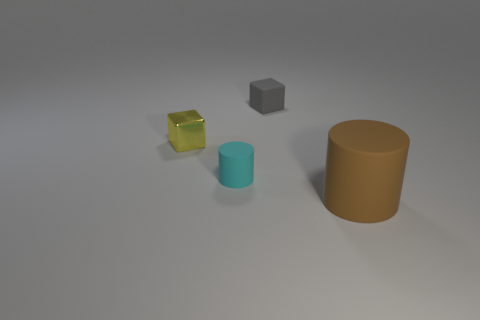Subtract all gray blocks. How many blocks are left? 1 Subtract 1 cylinders. How many cylinders are left? 1 Add 2 big red objects. How many objects exist? 6 Subtract all gray blocks. Subtract all gray cylinders. How many blocks are left? 1 Subtract all yellow cubes. Subtract all tiny things. How many objects are left? 0 Add 4 small cyan cylinders. How many small cyan cylinders are left? 5 Add 4 shiny cubes. How many shiny cubes exist? 5 Subtract 0 blue blocks. How many objects are left? 4 